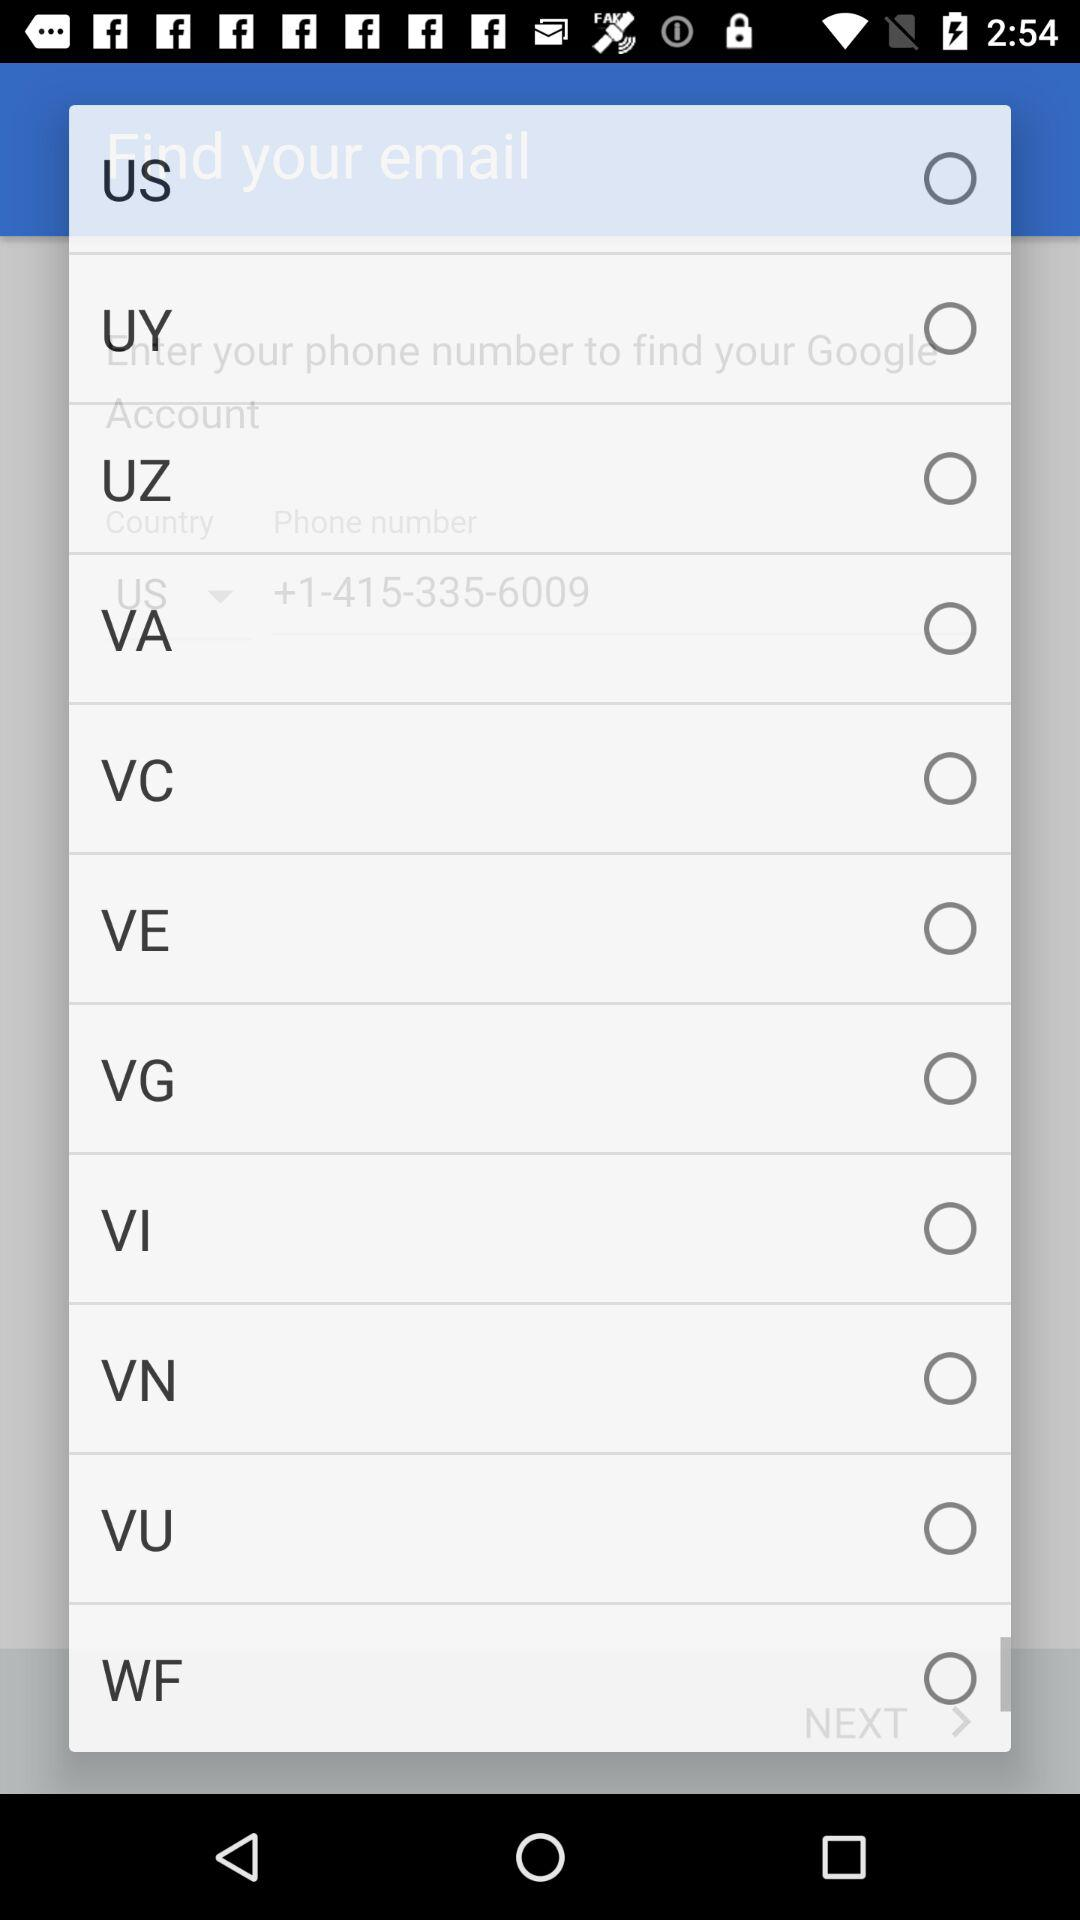Is "US" selected or not? It is not selected. 